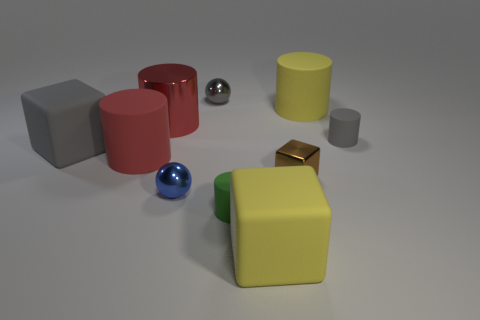Is the number of purple matte spheres greater than the number of small gray balls? no 